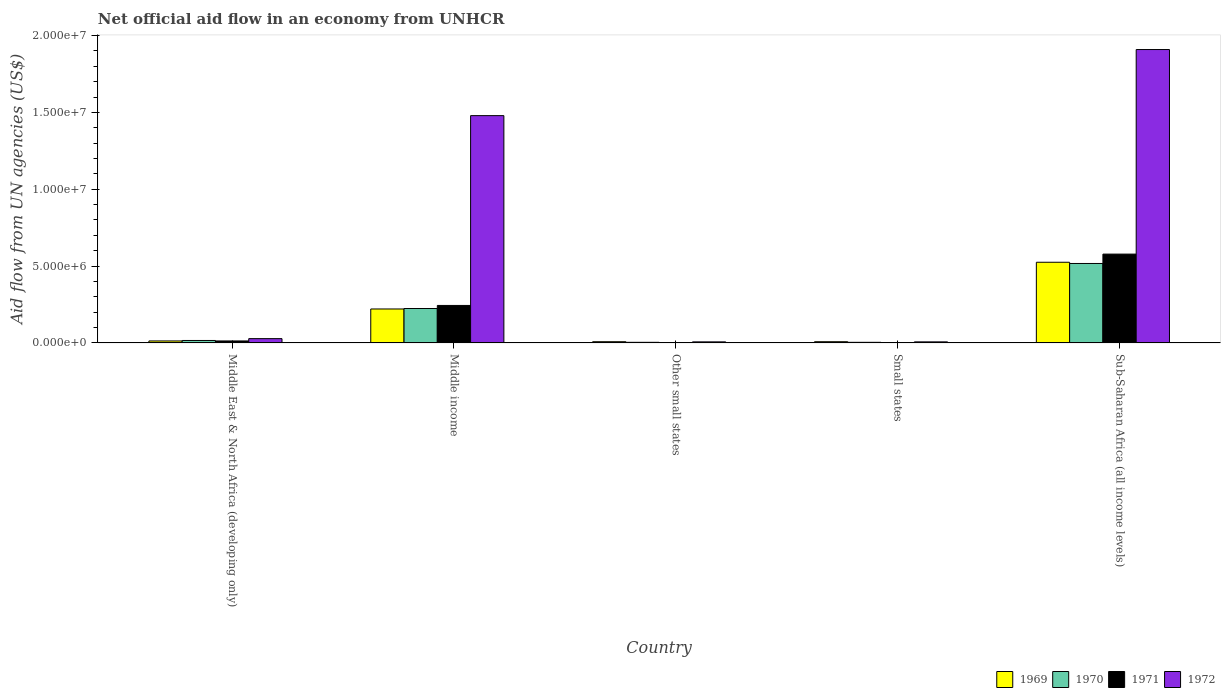How many different coloured bars are there?
Make the answer very short. 4. How many groups of bars are there?
Your response must be concise. 5. Are the number of bars per tick equal to the number of legend labels?
Your answer should be very brief. Yes. Are the number of bars on each tick of the X-axis equal?
Your answer should be compact. Yes. How many bars are there on the 3rd tick from the right?
Provide a succinct answer. 4. What is the label of the 5th group of bars from the left?
Give a very brief answer. Sub-Saharan Africa (all income levels). Across all countries, what is the maximum net official aid flow in 1970?
Ensure brevity in your answer.  5.17e+06. Across all countries, what is the minimum net official aid flow in 1970?
Give a very brief answer. 4.00e+04. In which country was the net official aid flow in 1972 maximum?
Offer a terse response. Sub-Saharan Africa (all income levels). In which country was the net official aid flow in 1970 minimum?
Your response must be concise. Other small states. What is the total net official aid flow in 1969 in the graph?
Give a very brief answer. 7.75e+06. What is the difference between the net official aid flow in 1970 in Other small states and that in Sub-Saharan Africa (all income levels)?
Keep it short and to the point. -5.13e+06. What is the difference between the net official aid flow in 1970 in Other small states and the net official aid flow in 1971 in Sub-Saharan Africa (all income levels)?
Your answer should be very brief. -5.74e+06. What is the average net official aid flow in 1970 per country?
Make the answer very short. 1.53e+06. What is the difference between the net official aid flow of/in 1969 and net official aid flow of/in 1971 in Small states?
Ensure brevity in your answer.  6.00e+04. In how many countries, is the net official aid flow in 1969 greater than 4000000 US$?
Give a very brief answer. 1. What is the ratio of the net official aid flow in 1969 in Middle East & North Africa (developing only) to that in Other small states?
Provide a succinct answer. 1.62. Is the difference between the net official aid flow in 1969 in Middle income and Sub-Saharan Africa (all income levels) greater than the difference between the net official aid flow in 1971 in Middle income and Sub-Saharan Africa (all income levels)?
Keep it short and to the point. Yes. What is the difference between the highest and the second highest net official aid flow in 1970?
Offer a terse response. 2.93e+06. What is the difference between the highest and the lowest net official aid flow in 1972?
Make the answer very short. 1.90e+07. In how many countries, is the net official aid flow in 1969 greater than the average net official aid flow in 1969 taken over all countries?
Your response must be concise. 2. Is it the case that in every country, the sum of the net official aid flow in 1970 and net official aid flow in 1971 is greater than the sum of net official aid flow in 1972 and net official aid flow in 1969?
Offer a very short reply. No. What does the 3rd bar from the left in Other small states represents?
Keep it short and to the point. 1971. What does the 1st bar from the right in Sub-Saharan Africa (all income levels) represents?
Your answer should be very brief. 1972. How many bars are there?
Offer a terse response. 20. How many countries are there in the graph?
Offer a terse response. 5. What is the difference between two consecutive major ticks on the Y-axis?
Make the answer very short. 5.00e+06. Are the values on the major ticks of Y-axis written in scientific E-notation?
Your answer should be compact. Yes. Does the graph contain any zero values?
Make the answer very short. No. Where does the legend appear in the graph?
Ensure brevity in your answer.  Bottom right. How many legend labels are there?
Offer a terse response. 4. What is the title of the graph?
Provide a succinct answer. Net official aid flow in an economy from UNHCR. Does "1976" appear as one of the legend labels in the graph?
Ensure brevity in your answer.  No. What is the label or title of the X-axis?
Provide a short and direct response. Country. What is the label or title of the Y-axis?
Keep it short and to the point. Aid flow from UN agencies (US$). What is the Aid flow from UN agencies (US$) in 1969 in Middle income?
Your answer should be very brief. 2.21e+06. What is the Aid flow from UN agencies (US$) of 1970 in Middle income?
Ensure brevity in your answer.  2.24e+06. What is the Aid flow from UN agencies (US$) in 1971 in Middle income?
Offer a terse response. 2.44e+06. What is the Aid flow from UN agencies (US$) of 1972 in Middle income?
Give a very brief answer. 1.48e+07. What is the Aid flow from UN agencies (US$) in 1969 in Other small states?
Keep it short and to the point. 8.00e+04. What is the Aid flow from UN agencies (US$) of 1970 in Other small states?
Give a very brief answer. 4.00e+04. What is the Aid flow from UN agencies (US$) in 1972 in Other small states?
Your answer should be compact. 7.00e+04. What is the Aid flow from UN agencies (US$) in 1972 in Small states?
Ensure brevity in your answer.  7.00e+04. What is the Aid flow from UN agencies (US$) in 1969 in Sub-Saharan Africa (all income levels)?
Your response must be concise. 5.25e+06. What is the Aid flow from UN agencies (US$) in 1970 in Sub-Saharan Africa (all income levels)?
Make the answer very short. 5.17e+06. What is the Aid flow from UN agencies (US$) in 1971 in Sub-Saharan Africa (all income levels)?
Keep it short and to the point. 5.78e+06. What is the Aid flow from UN agencies (US$) in 1972 in Sub-Saharan Africa (all income levels)?
Make the answer very short. 1.91e+07. Across all countries, what is the maximum Aid flow from UN agencies (US$) in 1969?
Provide a short and direct response. 5.25e+06. Across all countries, what is the maximum Aid flow from UN agencies (US$) of 1970?
Ensure brevity in your answer.  5.17e+06. Across all countries, what is the maximum Aid flow from UN agencies (US$) of 1971?
Ensure brevity in your answer.  5.78e+06. Across all countries, what is the maximum Aid flow from UN agencies (US$) of 1972?
Your answer should be compact. 1.91e+07. Across all countries, what is the minimum Aid flow from UN agencies (US$) of 1969?
Give a very brief answer. 8.00e+04. Across all countries, what is the minimum Aid flow from UN agencies (US$) in 1971?
Make the answer very short. 2.00e+04. Across all countries, what is the minimum Aid flow from UN agencies (US$) of 1972?
Your answer should be compact. 7.00e+04. What is the total Aid flow from UN agencies (US$) of 1969 in the graph?
Your response must be concise. 7.75e+06. What is the total Aid flow from UN agencies (US$) in 1970 in the graph?
Offer a terse response. 7.65e+06. What is the total Aid flow from UN agencies (US$) of 1971 in the graph?
Offer a very short reply. 8.39e+06. What is the total Aid flow from UN agencies (US$) in 1972 in the graph?
Your response must be concise. 3.43e+07. What is the difference between the Aid flow from UN agencies (US$) of 1969 in Middle East & North Africa (developing only) and that in Middle income?
Offer a very short reply. -2.08e+06. What is the difference between the Aid flow from UN agencies (US$) in 1970 in Middle East & North Africa (developing only) and that in Middle income?
Provide a succinct answer. -2.08e+06. What is the difference between the Aid flow from UN agencies (US$) of 1971 in Middle East & North Africa (developing only) and that in Middle income?
Offer a terse response. -2.31e+06. What is the difference between the Aid flow from UN agencies (US$) in 1972 in Middle East & North Africa (developing only) and that in Middle income?
Your response must be concise. -1.45e+07. What is the difference between the Aid flow from UN agencies (US$) of 1969 in Middle East & North Africa (developing only) and that in Other small states?
Your response must be concise. 5.00e+04. What is the difference between the Aid flow from UN agencies (US$) of 1970 in Middle East & North Africa (developing only) and that in Other small states?
Your response must be concise. 1.20e+05. What is the difference between the Aid flow from UN agencies (US$) in 1969 in Middle East & North Africa (developing only) and that in Small states?
Provide a succinct answer. 5.00e+04. What is the difference between the Aid flow from UN agencies (US$) in 1970 in Middle East & North Africa (developing only) and that in Small states?
Give a very brief answer. 1.20e+05. What is the difference between the Aid flow from UN agencies (US$) of 1971 in Middle East & North Africa (developing only) and that in Small states?
Your answer should be very brief. 1.10e+05. What is the difference between the Aid flow from UN agencies (US$) of 1969 in Middle East & North Africa (developing only) and that in Sub-Saharan Africa (all income levels)?
Offer a terse response. -5.12e+06. What is the difference between the Aid flow from UN agencies (US$) of 1970 in Middle East & North Africa (developing only) and that in Sub-Saharan Africa (all income levels)?
Your answer should be compact. -5.01e+06. What is the difference between the Aid flow from UN agencies (US$) of 1971 in Middle East & North Africa (developing only) and that in Sub-Saharan Africa (all income levels)?
Offer a very short reply. -5.65e+06. What is the difference between the Aid flow from UN agencies (US$) in 1972 in Middle East & North Africa (developing only) and that in Sub-Saharan Africa (all income levels)?
Keep it short and to the point. -1.88e+07. What is the difference between the Aid flow from UN agencies (US$) of 1969 in Middle income and that in Other small states?
Make the answer very short. 2.13e+06. What is the difference between the Aid flow from UN agencies (US$) in 1970 in Middle income and that in Other small states?
Offer a terse response. 2.20e+06. What is the difference between the Aid flow from UN agencies (US$) of 1971 in Middle income and that in Other small states?
Your answer should be very brief. 2.42e+06. What is the difference between the Aid flow from UN agencies (US$) of 1972 in Middle income and that in Other small states?
Make the answer very short. 1.47e+07. What is the difference between the Aid flow from UN agencies (US$) of 1969 in Middle income and that in Small states?
Your answer should be compact. 2.13e+06. What is the difference between the Aid flow from UN agencies (US$) in 1970 in Middle income and that in Small states?
Keep it short and to the point. 2.20e+06. What is the difference between the Aid flow from UN agencies (US$) of 1971 in Middle income and that in Small states?
Make the answer very short. 2.42e+06. What is the difference between the Aid flow from UN agencies (US$) in 1972 in Middle income and that in Small states?
Provide a succinct answer. 1.47e+07. What is the difference between the Aid flow from UN agencies (US$) in 1969 in Middle income and that in Sub-Saharan Africa (all income levels)?
Keep it short and to the point. -3.04e+06. What is the difference between the Aid flow from UN agencies (US$) in 1970 in Middle income and that in Sub-Saharan Africa (all income levels)?
Your answer should be compact. -2.93e+06. What is the difference between the Aid flow from UN agencies (US$) of 1971 in Middle income and that in Sub-Saharan Africa (all income levels)?
Provide a short and direct response. -3.34e+06. What is the difference between the Aid flow from UN agencies (US$) of 1972 in Middle income and that in Sub-Saharan Africa (all income levels)?
Provide a short and direct response. -4.30e+06. What is the difference between the Aid flow from UN agencies (US$) in 1969 in Other small states and that in Small states?
Make the answer very short. 0. What is the difference between the Aid flow from UN agencies (US$) of 1971 in Other small states and that in Small states?
Offer a terse response. 0. What is the difference between the Aid flow from UN agencies (US$) of 1969 in Other small states and that in Sub-Saharan Africa (all income levels)?
Keep it short and to the point. -5.17e+06. What is the difference between the Aid flow from UN agencies (US$) in 1970 in Other small states and that in Sub-Saharan Africa (all income levels)?
Your answer should be very brief. -5.13e+06. What is the difference between the Aid flow from UN agencies (US$) of 1971 in Other small states and that in Sub-Saharan Africa (all income levels)?
Provide a succinct answer. -5.76e+06. What is the difference between the Aid flow from UN agencies (US$) in 1972 in Other small states and that in Sub-Saharan Africa (all income levels)?
Provide a succinct answer. -1.90e+07. What is the difference between the Aid flow from UN agencies (US$) in 1969 in Small states and that in Sub-Saharan Africa (all income levels)?
Your answer should be compact. -5.17e+06. What is the difference between the Aid flow from UN agencies (US$) in 1970 in Small states and that in Sub-Saharan Africa (all income levels)?
Offer a very short reply. -5.13e+06. What is the difference between the Aid flow from UN agencies (US$) in 1971 in Small states and that in Sub-Saharan Africa (all income levels)?
Make the answer very short. -5.76e+06. What is the difference between the Aid flow from UN agencies (US$) in 1972 in Small states and that in Sub-Saharan Africa (all income levels)?
Keep it short and to the point. -1.90e+07. What is the difference between the Aid flow from UN agencies (US$) of 1969 in Middle East & North Africa (developing only) and the Aid flow from UN agencies (US$) of 1970 in Middle income?
Your answer should be very brief. -2.11e+06. What is the difference between the Aid flow from UN agencies (US$) in 1969 in Middle East & North Africa (developing only) and the Aid flow from UN agencies (US$) in 1971 in Middle income?
Provide a succinct answer. -2.31e+06. What is the difference between the Aid flow from UN agencies (US$) of 1969 in Middle East & North Africa (developing only) and the Aid flow from UN agencies (US$) of 1972 in Middle income?
Your answer should be very brief. -1.47e+07. What is the difference between the Aid flow from UN agencies (US$) of 1970 in Middle East & North Africa (developing only) and the Aid flow from UN agencies (US$) of 1971 in Middle income?
Offer a terse response. -2.28e+06. What is the difference between the Aid flow from UN agencies (US$) in 1970 in Middle East & North Africa (developing only) and the Aid flow from UN agencies (US$) in 1972 in Middle income?
Your answer should be compact. -1.46e+07. What is the difference between the Aid flow from UN agencies (US$) in 1971 in Middle East & North Africa (developing only) and the Aid flow from UN agencies (US$) in 1972 in Middle income?
Your response must be concise. -1.47e+07. What is the difference between the Aid flow from UN agencies (US$) of 1969 in Middle East & North Africa (developing only) and the Aid flow from UN agencies (US$) of 1972 in Other small states?
Offer a very short reply. 6.00e+04. What is the difference between the Aid flow from UN agencies (US$) in 1971 in Middle East & North Africa (developing only) and the Aid flow from UN agencies (US$) in 1972 in Other small states?
Offer a very short reply. 6.00e+04. What is the difference between the Aid flow from UN agencies (US$) in 1970 in Middle East & North Africa (developing only) and the Aid flow from UN agencies (US$) in 1972 in Small states?
Make the answer very short. 9.00e+04. What is the difference between the Aid flow from UN agencies (US$) in 1969 in Middle East & North Africa (developing only) and the Aid flow from UN agencies (US$) in 1970 in Sub-Saharan Africa (all income levels)?
Provide a succinct answer. -5.04e+06. What is the difference between the Aid flow from UN agencies (US$) of 1969 in Middle East & North Africa (developing only) and the Aid flow from UN agencies (US$) of 1971 in Sub-Saharan Africa (all income levels)?
Provide a short and direct response. -5.65e+06. What is the difference between the Aid flow from UN agencies (US$) of 1969 in Middle East & North Africa (developing only) and the Aid flow from UN agencies (US$) of 1972 in Sub-Saharan Africa (all income levels)?
Ensure brevity in your answer.  -1.90e+07. What is the difference between the Aid flow from UN agencies (US$) in 1970 in Middle East & North Africa (developing only) and the Aid flow from UN agencies (US$) in 1971 in Sub-Saharan Africa (all income levels)?
Give a very brief answer. -5.62e+06. What is the difference between the Aid flow from UN agencies (US$) of 1970 in Middle East & North Africa (developing only) and the Aid flow from UN agencies (US$) of 1972 in Sub-Saharan Africa (all income levels)?
Ensure brevity in your answer.  -1.89e+07. What is the difference between the Aid flow from UN agencies (US$) in 1971 in Middle East & North Africa (developing only) and the Aid flow from UN agencies (US$) in 1972 in Sub-Saharan Africa (all income levels)?
Provide a succinct answer. -1.90e+07. What is the difference between the Aid flow from UN agencies (US$) in 1969 in Middle income and the Aid flow from UN agencies (US$) in 1970 in Other small states?
Ensure brevity in your answer.  2.17e+06. What is the difference between the Aid flow from UN agencies (US$) in 1969 in Middle income and the Aid flow from UN agencies (US$) in 1971 in Other small states?
Provide a succinct answer. 2.19e+06. What is the difference between the Aid flow from UN agencies (US$) in 1969 in Middle income and the Aid flow from UN agencies (US$) in 1972 in Other small states?
Make the answer very short. 2.14e+06. What is the difference between the Aid flow from UN agencies (US$) of 1970 in Middle income and the Aid flow from UN agencies (US$) of 1971 in Other small states?
Make the answer very short. 2.22e+06. What is the difference between the Aid flow from UN agencies (US$) of 1970 in Middle income and the Aid flow from UN agencies (US$) of 1972 in Other small states?
Keep it short and to the point. 2.17e+06. What is the difference between the Aid flow from UN agencies (US$) in 1971 in Middle income and the Aid flow from UN agencies (US$) in 1972 in Other small states?
Your answer should be compact. 2.37e+06. What is the difference between the Aid flow from UN agencies (US$) of 1969 in Middle income and the Aid flow from UN agencies (US$) of 1970 in Small states?
Offer a very short reply. 2.17e+06. What is the difference between the Aid flow from UN agencies (US$) of 1969 in Middle income and the Aid flow from UN agencies (US$) of 1971 in Small states?
Your answer should be very brief. 2.19e+06. What is the difference between the Aid flow from UN agencies (US$) in 1969 in Middle income and the Aid flow from UN agencies (US$) in 1972 in Small states?
Make the answer very short. 2.14e+06. What is the difference between the Aid flow from UN agencies (US$) of 1970 in Middle income and the Aid flow from UN agencies (US$) of 1971 in Small states?
Ensure brevity in your answer.  2.22e+06. What is the difference between the Aid flow from UN agencies (US$) of 1970 in Middle income and the Aid flow from UN agencies (US$) of 1972 in Small states?
Your answer should be compact. 2.17e+06. What is the difference between the Aid flow from UN agencies (US$) in 1971 in Middle income and the Aid flow from UN agencies (US$) in 1972 in Small states?
Your answer should be very brief. 2.37e+06. What is the difference between the Aid flow from UN agencies (US$) in 1969 in Middle income and the Aid flow from UN agencies (US$) in 1970 in Sub-Saharan Africa (all income levels)?
Provide a succinct answer. -2.96e+06. What is the difference between the Aid flow from UN agencies (US$) of 1969 in Middle income and the Aid flow from UN agencies (US$) of 1971 in Sub-Saharan Africa (all income levels)?
Offer a very short reply. -3.57e+06. What is the difference between the Aid flow from UN agencies (US$) in 1969 in Middle income and the Aid flow from UN agencies (US$) in 1972 in Sub-Saharan Africa (all income levels)?
Ensure brevity in your answer.  -1.69e+07. What is the difference between the Aid flow from UN agencies (US$) of 1970 in Middle income and the Aid flow from UN agencies (US$) of 1971 in Sub-Saharan Africa (all income levels)?
Provide a short and direct response. -3.54e+06. What is the difference between the Aid flow from UN agencies (US$) of 1970 in Middle income and the Aid flow from UN agencies (US$) of 1972 in Sub-Saharan Africa (all income levels)?
Provide a succinct answer. -1.68e+07. What is the difference between the Aid flow from UN agencies (US$) of 1971 in Middle income and the Aid flow from UN agencies (US$) of 1972 in Sub-Saharan Africa (all income levels)?
Provide a short and direct response. -1.66e+07. What is the difference between the Aid flow from UN agencies (US$) of 1969 in Other small states and the Aid flow from UN agencies (US$) of 1971 in Small states?
Your response must be concise. 6.00e+04. What is the difference between the Aid flow from UN agencies (US$) of 1970 in Other small states and the Aid flow from UN agencies (US$) of 1972 in Small states?
Make the answer very short. -3.00e+04. What is the difference between the Aid flow from UN agencies (US$) in 1971 in Other small states and the Aid flow from UN agencies (US$) in 1972 in Small states?
Your answer should be compact. -5.00e+04. What is the difference between the Aid flow from UN agencies (US$) in 1969 in Other small states and the Aid flow from UN agencies (US$) in 1970 in Sub-Saharan Africa (all income levels)?
Provide a succinct answer. -5.09e+06. What is the difference between the Aid flow from UN agencies (US$) of 1969 in Other small states and the Aid flow from UN agencies (US$) of 1971 in Sub-Saharan Africa (all income levels)?
Your response must be concise. -5.70e+06. What is the difference between the Aid flow from UN agencies (US$) of 1969 in Other small states and the Aid flow from UN agencies (US$) of 1972 in Sub-Saharan Africa (all income levels)?
Make the answer very short. -1.90e+07. What is the difference between the Aid flow from UN agencies (US$) of 1970 in Other small states and the Aid flow from UN agencies (US$) of 1971 in Sub-Saharan Africa (all income levels)?
Your answer should be compact. -5.74e+06. What is the difference between the Aid flow from UN agencies (US$) of 1970 in Other small states and the Aid flow from UN agencies (US$) of 1972 in Sub-Saharan Africa (all income levels)?
Offer a terse response. -1.90e+07. What is the difference between the Aid flow from UN agencies (US$) in 1971 in Other small states and the Aid flow from UN agencies (US$) in 1972 in Sub-Saharan Africa (all income levels)?
Offer a terse response. -1.91e+07. What is the difference between the Aid flow from UN agencies (US$) of 1969 in Small states and the Aid flow from UN agencies (US$) of 1970 in Sub-Saharan Africa (all income levels)?
Make the answer very short. -5.09e+06. What is the difference between the Aid flow from UN agencies (US$) in 1969 in Small states and the Aid flow from UN agencies (US$) in 1971 in Sub-Saharan Africa (all income levels)?
Your answer should be very brief. -5.70e+06. What is the difference between the Aid flow from UN agencies (US$) of 1969 in Small states and the Aid flow from UN agencies (US$) of 1972 in Sub-Saharan Africa (all income levels)?
Your response must be concise. -1.90e+07. What is the difference between the Aid flow from UN agencies (US$) of 1970 in Small states and the Aid flow from UN agencies (US$) of 1971 in Sub-Saharan Africa (all income levels)?
Provide a succinct answer. -5.74e+06. What is the difference between the Aid flow from UN agencies (US$) in 1970 in Small states and the Aid flow from UN agencies (US$) in 1972 in Sub-Saharan Africa (all income levels)?
Ensure brevity in your answer.  -1.90e+07. What is the difference between the Aid flow from UN agencies (US$) of 1971 in Small states and the Aid flow from UN agencies (US$) of 1972 in Sub-Saharan Africa (all income levels)?
Make the answer very short. -1.91e+07. What is the average Aid flow from UN agencies (US$) in 1969 per country?
Provide a succinct answer. 1.55e+06. What is the average Aid flow from UN agencies (US$) of 1970 per country?
Your answer should be compact. 1.53e+06. What is the average Aid flow from UN agencies (US$) in 1971 per country?
Keep it short and to the point. 1.68e+06. What is the average Aid flow from UN agencies (US$) of 1972 per country?
Ensure brevity in your answer.  6.86e+06. What is the difference between the Aid flow from UN agencies (US$) in 1969 and Aid flow from UN agencies (US$) in 1971 in Middle East & North Africa (developing only)?
Your answer should be compact. 0. What is the difference between the Aid flow from UN agencies (US$) of 1970 and Aid flow from UN agencies (US$) of 1971 in Middle East & North Africa (developing only)?
Provide a short and direct response. 3.00e+04. What is the difference between the Aid flow from UN agencies (US$) of 1970 and Aid flow from UN agencies (US$) of 1972 in Middle East & North Africa (developing only)?
Your answer should be compact. -1.20e+05. What is the difference between the Aid flow from UN agencies (US$) in 1971 and Aid flow from UN agencies (US$) in 1972 in Middle East & North Africa (developing only)?
Your answer should be very brief. -1.50e+05. What is the difference between the Aid flow from UN agencies (US$) in 1969 and Aid flow from UN agencies (US$) in 1970 in Middle income?
Your answer should be very brief. -3.00e+04. What is the difference between the Aid flow from UN agencies (US$) in 1969 and Aid flow from UN agencies (US$) in 1972 in Middle income?
Provide a short and direct response. -1.26e+07. What is the difference between the Aid flow from UN agencies (US$) of 1970 and Aid flow from UN agencies (US$) of 1972 in Middle income?
Provide a succinct answer. -1.26e+07. What is the difference between the Aid flow from UN agencies (US$) of 1971 and Aid flow from UN agencies (US$) of 1972 in Middle income?
Offer a terse response. -1.24e+07. What is the difference between the Aid flow from UN agencies (US$) of 1969 and Aid flow from UN agencies (US$) of 1972 in Other small states?
Your answer should be compact. 10000. What is the difference between the Aid flow from UN agencies (US$) of 1970 and Aid flow from UN agencies (US$) of 1972 in Other small states?
Give a very brief answer. -3.00e+04. What is the difference between the Aid flow from UN agencies (US$) in 1969 and Aid flow from UN agencies (US$) in 1972 in Small states?
Provide a succinct answer. 10000. What is the difference between the Aid flow from UN agencies (US$) in 1970 and Aid flow from UN agencies (US$) in 1972 in Small states?
Your answer should be very brief. -3.00e+04. What is the difference between the Aid flow from UN agencies (US$) of 1969 and Aid flow from UN agencies (US$) of 1971 in Sub-Saharan Africa (all income levels)?
Keep it short and to the point. -5.30e+05. What is the difference between the Aid flow from UN agencies (US$) of 1969 and Aid flow from UN agencies (US$) of 1972 in Sub-Saharan Africa (all income levels)?
Your response must be concise. -1.38e+07. What is the difference between the Aid flow from UN agencies (US$) of 1970 and Aid flow from UN agencies (US$) of 1971 in Sub-Saharan Africa (all income levels)?
Your response must be concise. -6.10e+05. What is the difference between the Aid flow from UN agencies (US$) of 1970 and Aid flow from UN agencies (US$) of 1972 in Sub-Saharan Africa (all income levels)?
Ensure brevity in your answer.  -1.39e+07. What is the difference between the Aid flow from UN agencies (US$) of 1971 and Aid flow from UN agencies (US$) of 1972 in Sub-Saharan Africa (all income levels)?
Provide a short and direct response. -1.33e+07. What is the ratio of the Aid flow from UN agencies (US$) in 1969 in Middle East & North Africa (developing only) to that in Middle income?
Make the answer very short. 0.06. What is the ratio of the Aid flow from UN agencies (US$) of 1970 in Middle East & North Africa (developing only) to that in Middle income?
Your response must be concise. 0.07. What is the ratio of the Aid flow from UN agencies (US$) in 1971 in Middle East & North Africa (developing only) to that in Middle income?
Provide a short and direct response. 0.05. What is the ratio of the Aid flow from UN agencies (US$) in 1972 in Middle East & North Africa (developing only) to that in Middle income?
Keep it short and to the point. 0.02. What is the ratio of the Aid flow from UN agencies (US$) of 1969 in Middle East & North Africa (developing only) to that in Other small states?
Your response must be concise. 1.62. What is the ratio of the Aid flow from UN agencies (US$) in 1971 in Middle East & North Africa (developing only) to that in Other small states?
Give a very brief answer. 6.5. What is the ratio of the Aid flow from UN agencies (US$) in 1969 in Middle East & North Africa (developing only) to that in Small states?
Keep it short and to the point. 1.62. What is the ratio of the Aid flow from UN agencies (US$) of 1970 in Middle East & North Africa (developing only) to that in Small states?
Your response must be concise. 4. What is the ratio of the Aid flow from UN agencies (US$) of 1971 in Middle East & North Africa (developing only) to that in Small states?
Provide a succinct answer. 6.5. What is the ratio of the Aid flow from UN agencies (US$) of 1972 in Middle East & North Africa (developing only) to that in Small states?
Your response must be concise. 4. What is the ratio of the Aid flow from UN agencies (US$) in 1969 in Middle East & North Africa (developing only) to that in Sub-Saharan Africa (all income levels)?
Keep it short and to the point. 0.02. What is the ratio of the Aid flow from UN agencies (US$) of 1970 in Middle East & North Africa (developing only) to that in Sub-Saharan Africa (all income levels)?
Offer a terse response. 0.03. What is the ratio of the Aid flow from UN agencies (US$) of 1971 in Middle East & North Africa (developing only) to that in Sub-Saharan Africa (all income levels)?
Keep it short and to the point. 0.02. What is the ratio of the Aid flow from UN agencies (US$) in 1972 in Middle East & North Africa (developing only) to that in Sub-Saharan Africa (all income levels)?
Provide a short and direct response. 0.01. What is the ratio of the Aid flow from UN agencies (US$) in 1969 in Middle income to that in Other small states?
Provide a succinct answer. 27.62. What is the ratio of the Aid flow from UN agencies (US$) of 1971 in Middle income to that in Other small states?
Make the answer very short. 122. What is the ratio of the Aid flow from UN agencies (US$) of 1972 in Middle income to that in Other small states?
Provide a short and direct response. 211.29. What is the ratio of the Aid flow from UN agencies (US$) in 1969 in Middle income to that in Small states?
Provide a short and direct response. 27.62. What is the ratio of the Aid flow from UN agencies (US$) in 1970 in Middle income to that in Small states?
Provide a succinct answer. 56. What is the ratio of the Aid flow from UN agencies (US$) of 1971 in Middle income to that in Small states?
Your answer should be very brief. 122. What is the ratio of the Aid flow from UN agencies (US$) in 1972 in Middle income to that in Small states?
Provide a short and direct response. 211.29. What is the ratio of the Aid flow from UN agencies (US$) of 1969 in Middle income to that in Sub-Saharan Africa (all income levels)?
Your answer should be compact. 0.42. What is the ratio of the Aid flow from UN agencies (US$) in 1970 in Middle income to that in Sub-Saharan Africa (all income levels)?
Ensure brevity in your answer.  0.43. What is the ratio of the Aid flow from UN agencies (US$) of 1971 in Middle income to that in Sub-Saharan Africa (all income levels)?
Keep it short and to the point. 0.42. What is the ratio of the Aid flow from UN agencies (US$) of 1972 in Middle income to that in Sub-Saharan Africa (all income levels)?
Provide a succinct answer. 0.77. What is the ratio of the Aid flow from UN agencies (US$) in 1970 in Other small states to that in Small states?
Your answer should be compact. 1. What is the ratio of the Aid flow from UN agencies (US$) of 1971 in Other small states to that in Small states?
Keep it short and to the point. 1. What is the ratio of the Aid flow from UN agencies (US$) in 1972 in Other small states to that in Small states?
Make the answer very short. 1. What is the ratio of the Aid flow from UN agencies (US$) in 1969 in Other small states to that in Sub-Saharan Africa (all income levels)?
Make the answer very short. 0.02. What is the ratio of the Aid flow from UN agencies (US$) of 1970 in Other small states to that in Sub-Saharan Africa (all income levels)?
Provide a short and direct response. 0.01. What is the ratio of the Aid flow from UN agencies (US$) of 1971 in Other small states to that in Sub-Saharan Africa (all income levels)?
Your answer should be very brief. 0. What is the ratio of the Aid flow from UN agencies (US$) in 1972 in Other small states to that in Sub-Saharan Africa (all income levels)?
Your response must be concise. 0. What is the ratio of the Aid flow from UN agencies (US$) of 1969 in Small states to that in Sub-Saharan Africa (all income levels)?
Give a very brief answer. 0.02. What is the ratio of the Aid flow from UN agencies (US$) of 1970 in Small states to that in Sub-Saharan Africa (all income levels)?
Offer a very short reply. 0.01. What is the ratio of the Aid flow from UN agencies (US$) of 1971 in Small states to that in Sub-Saharan Africa (all income levels)?
Your answer should be compact. 0. What is the ratio of the Aid flow from UN agencies (US$) in 1972 in Small states to that in Sub-Saharan Africa (all income levels)?
Provide a short and direct response. 0. What is the difference between the highest and the second highest Aid flow from UN agencies (US$) in 1969?
Provide a succinct answer. 3.04e+06. What is the difference between the highest and the second highest Aid flow from UN agencies (US$) in 1970?
Your answer should be very brief. 2.93e+06. What is the difference between the highest and the second highest Aid flow from UN agencies (US$) of 1971?
Make the answer very short. 3.34e+06. What is the difference between the highest and the second highest Aid flow from UN agencies (US$) in 1972?
Make the answer very short. 4.30e+06. What is the difference between the highest and the lowest Aid flow from UN agencies (US$) of 1969?
Ensure brevity in your answer.  5.17e+06. What is the difference between the highest and the lowest Aid flow from UN agencies (US$) of 1970?
Your answer should be compact. 5.13e+06. What is the difference between the highest and the lowest Aid flow from UN agencies (US$) in 1971?
Your answer should be very brief. 5.76e+06. What is the difference between the highest and the lowest Aid flow from UN agencies (US$) in 1972?
Keep it short and to the point. 1.90e+07. 